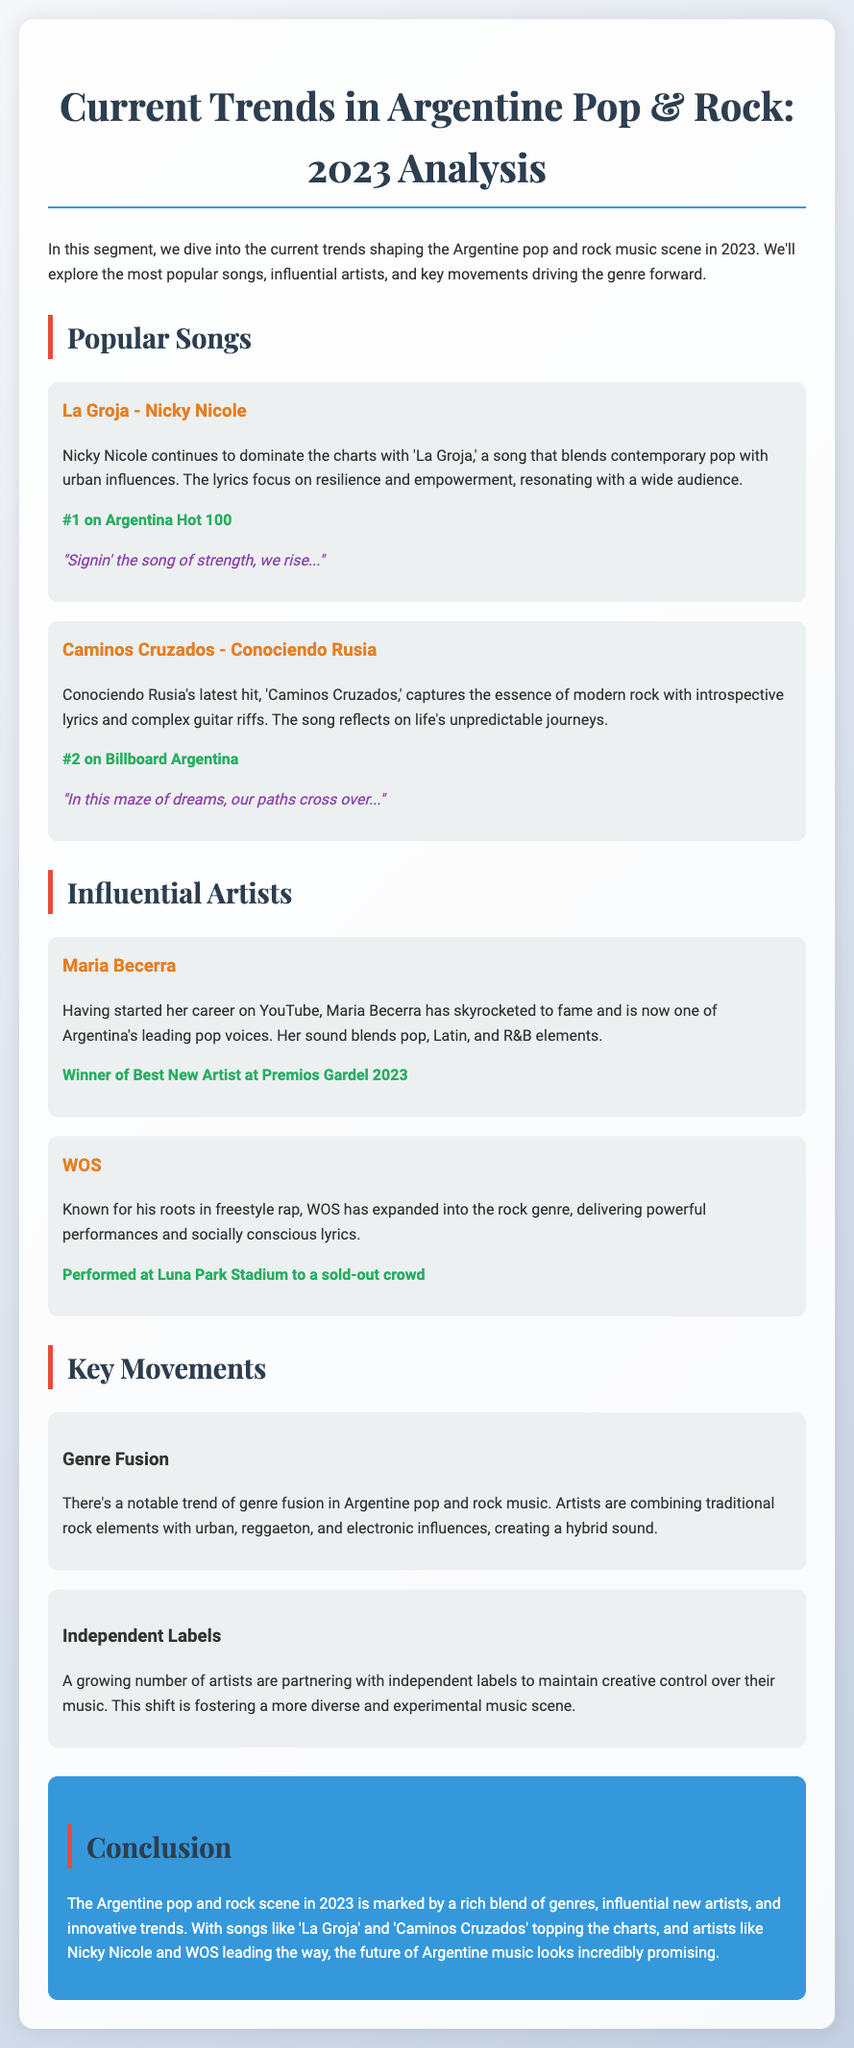What is the title of the most popular song? The title of the most popular song is stated in the document as 'La Groja' by Nicky Nicole.
Answer: 'La Groja' Who is the artist behind 'Caminos Cruzados'? The artist known for 'Caminos Cruzados' is Conociendo Rusia.
Answer: Conociendo Rusia What is Maria Becerra known for in 2023? Maria Becerra is recognized as the winner of Best New Artist at Premios Gardel 2023.
Answer: Best New Artist at Premios Gardel 2023 What is a key trend noted in the document? The document mentions genre fusion as a notable trend in Argentine pop and rock music.
Answer: Genre fusion How many popular songs are analyzed in the document? The document analyzes two popular songs: 'La Groja' and 'Caminos Cruzados'.
Answer: Two What was the chart position of 'La Groja'? The chart position of 'La Groja' is stated as #1 on Argentina Hot 100.
Answer: #1 on Argentina Hot 100 What genre is WOS associated with? WOS is associated with freestyle rap and has expanded into the rock genre.
Answer: Freestyle rap What type of artists are emerging according to the document? The document highlights a growing number of artists partnering with independent labels.
Answer: Independent artists 